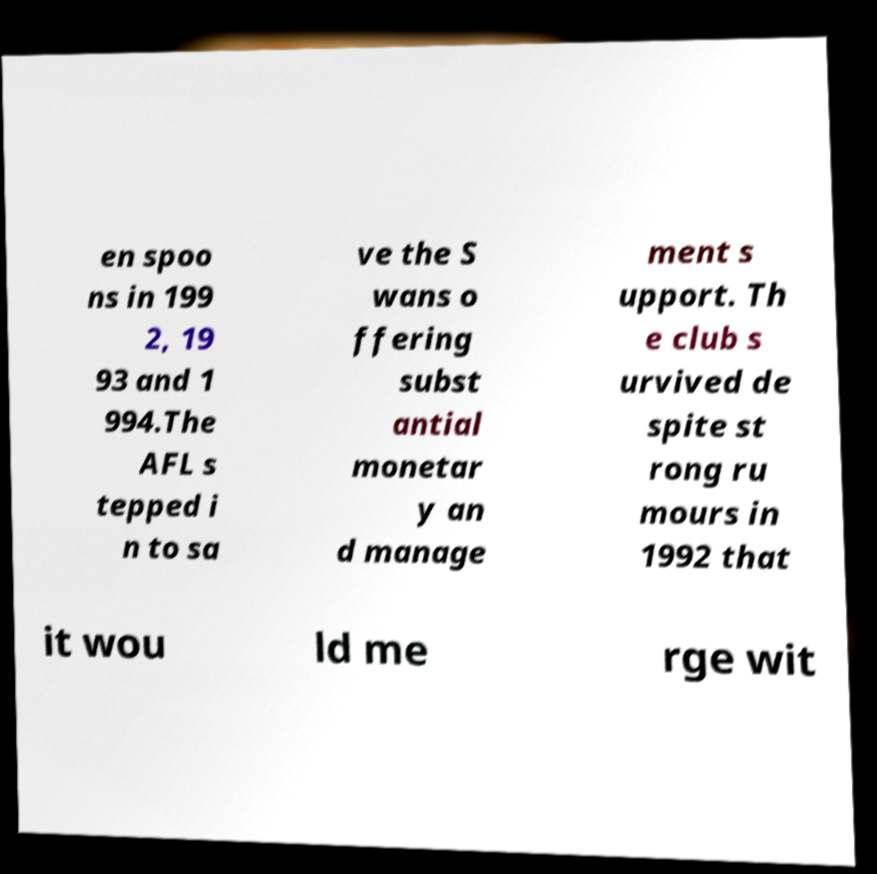Can you read and provide the text displayed in the image?This photo seems to have some interesting text. Can you extract and type it out for me? en spoo ns in 199 2, 19 93 and 1 994.The AFL s tepped i n to sa ve the S wans o ffering subst antial monetar y an d manage ment s upport. Th e club s urvived de spite st rong ru mours in 1992 that it wou ld me rge wit 